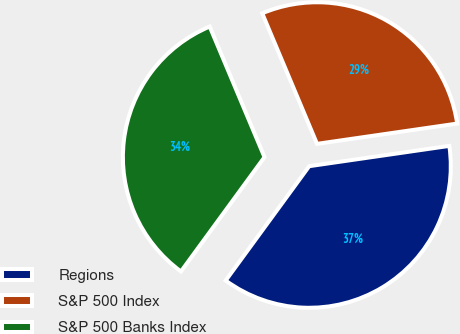<chart> <loc_0><loc_0><loc_500><loc_500><pie_chart><fcel>Regions<fcel>S&P 500 Index<fcel>S&P 500 Banks Index<nl><fcel>37.33%<fcel>29.04%<fcel>33.63%<nl></chart> 